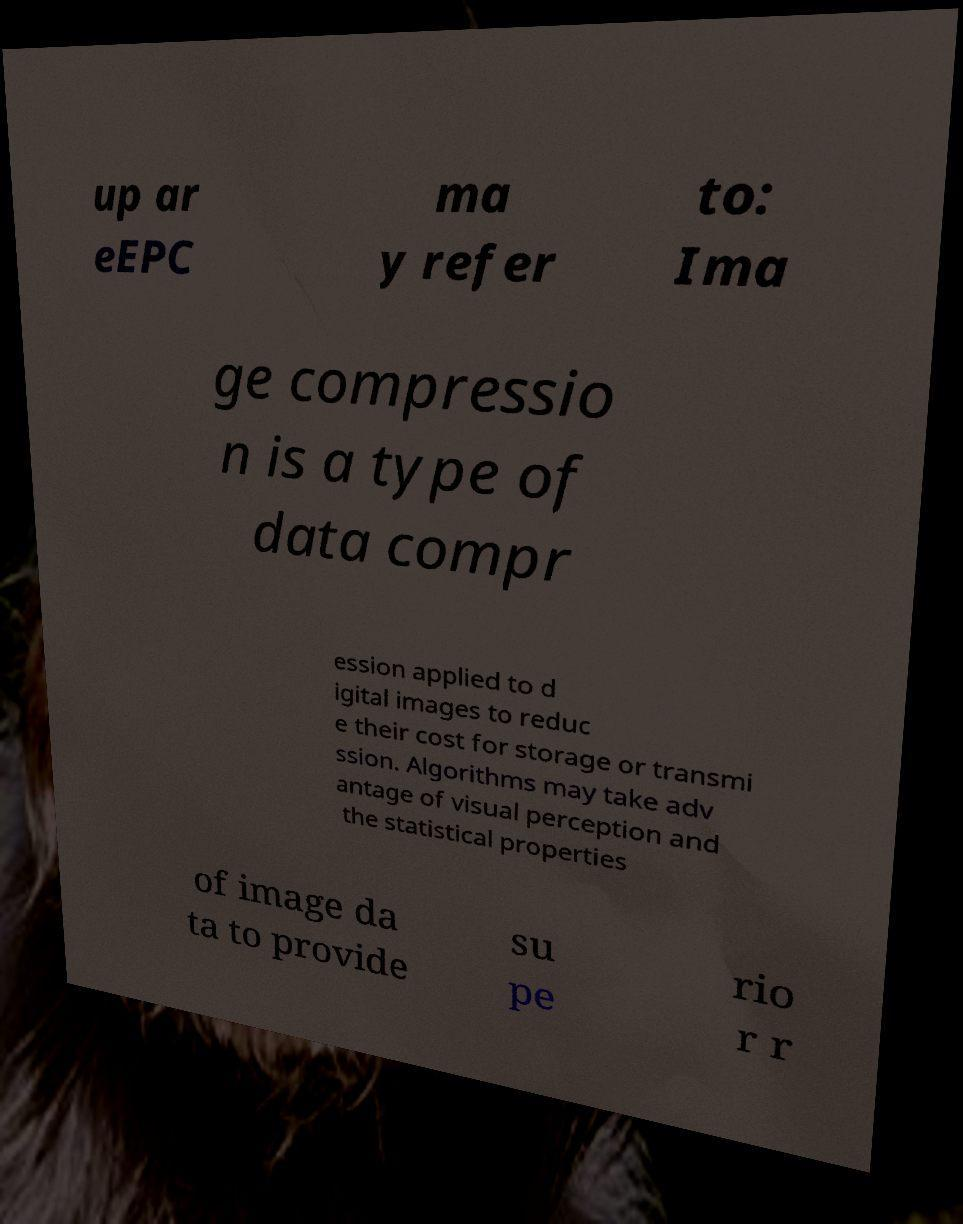For documentation purposes, I need the text within this image transcribed. Could you provide that? up ar eEPC ma y refer to: Ima ge compressio n is a type of data compr ession applied to d igital images to reduc e their cost for storage or transmi ssion. Algorithms may take adv antage of visual perception and the statistical properties of image da ta to provide su pe rio r r 